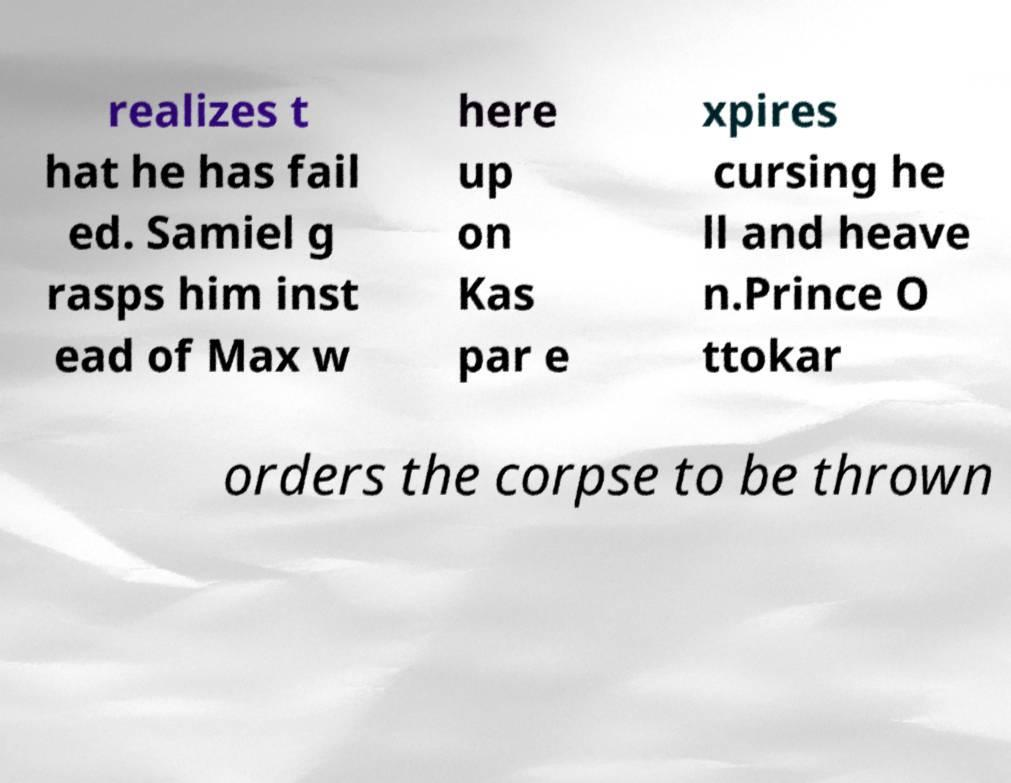Could you extract and type out the text from this image? realizes t hat he has fail ed. Samiel g rasps him inst ead of Max w here up on Kas par e xpires cursing he ll and heave n.Prince O ttokar orders the corpse to be thrown 